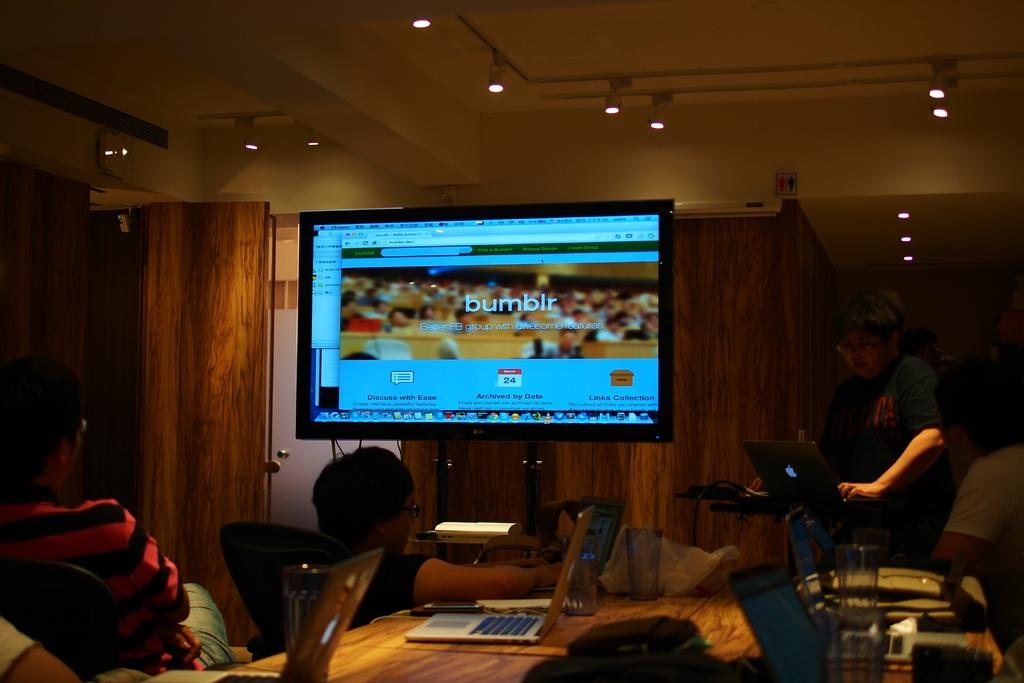<image>
Relay a brief, clear account of the picture shown. People on laptops at a conference table pay attention to a screen showing the Bumblr site. 